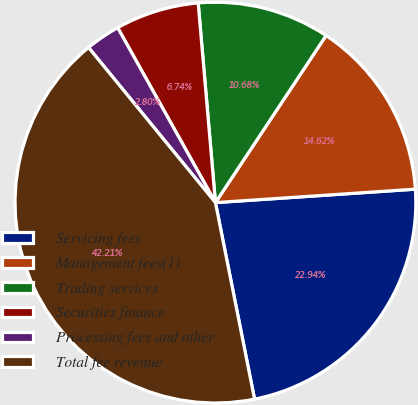Convert chart to OTSL. <chart><loc_0><loc_0><loc_500><loc_500><pie_chart><fcel>Servicing fees<fcel>Management fees(1)<fcel>Trading services<fcel>Securities finance<fcel>Processing fees and other<fcel>Total fee revenue<nl><fcel>22.94%<fcel>14.62%<fcel>10.68%<fcel>6.74%<fcel>2.8%<fcel>42.21%<nl></chart> 